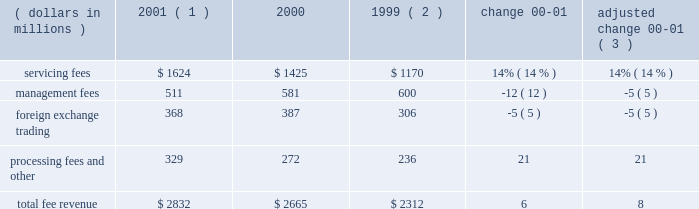An average of 7.1 in 2000 .
The top 100 largest clients used an average of 11.3 products in 2001 , up from an average of 11.2 in 2000 .
State street benefits significantly from its ability to derive revenue from the transaction flows of clients .
This occurs through the management of cash positions , including deposit balances and other short-term investment activities , using state street 2019s balance sheet capacity .
Significant foreign currency transaction volumes provide potential for foreign exchange trading revenue as well .
Fee revenue total operating fee revenuewas $ 2.8 billion in 2001 , compared to $ 2.7 billion in 2000 , an increase of 6% ( 6 % ) .
Adjusted for the formation of citistreet , the growth in fee revenue was 8% ( 8 % ) .
Growth in servicing fees of $ 199million , or 14% ( 14 % ) , was the primary contributor to the increase in fee revenue .
This growth primarily reflects several large client wins installed starting in the latter half of 2000 and continuing throughout 2001 , and strength in fee revenue from securities lending .
Declines in equity market values worldwide offset some of the growth in servicing fees .
Management fees were down 5% ( 5 % ) , adjusted for the formation of citistreet , reflecting the decline in theworldwide equitymarkets .
Foreign exchange trading revenue was down 5% ( 5 % ) , reflecting lower currency volatility , and processing fees and other revenue was up 21% ( 21 % ) , primarily due to gains on the sales of investment securities .
Servicing and management fees are a function of several factors , including the mix and volume of assets under custody and assets under management , securities positions held , and portfolio transactions , as well as types of products and services used by clients .
State street estimates , based on a study conducted in 2000 , that a 10% ( 10 % ) increase or decrease in worldwide equity values would cause a corresponding change in state street 2019s total revenue of approximately 2% ( 2 % ) .
If bond values were to increase or decrease by 10% ( 10 % ) , state street would anticipate a corresponding change of approximately 1% ( 1 % ) in its total revenue .
Securities lending revenue in 2001 increased approximately 40% ( 40 % ) over 2000 .
Securities lending revenue is reflected in both servicing fees and management fees .
Securities lending revenue is a function of the volume of securities lent and interest rate spreads .
While volumes increased in 2001 , the year-over-year increase is primarily due to wider interest rate spreads resulting from the unusual occurrence of eleven reductions in the u.s .
Federal funds target rate during 2001 .
F e e r e v e n u e ( dollars in millions ) 2001 ( 1 ) 2000 1999 ( 2 ) change adjusted change 00-01 ( 3 ) .
( 1 ) 2001 results exclude the write-off of state street 2019s total investment in bridge of $ 50 million ( 2 ) 1999 results exclude the one-time charge of $ 57 million related to the repositioning of the investment portfolio ( 3 ) 2000 results adjusted for the formation of citistreet 4 state street corporation .
What is the percent change of servicing fees between 1999 and 2000? 
Computations: ((1425 - 1170) / 1170)
Answer: 0.21795. 